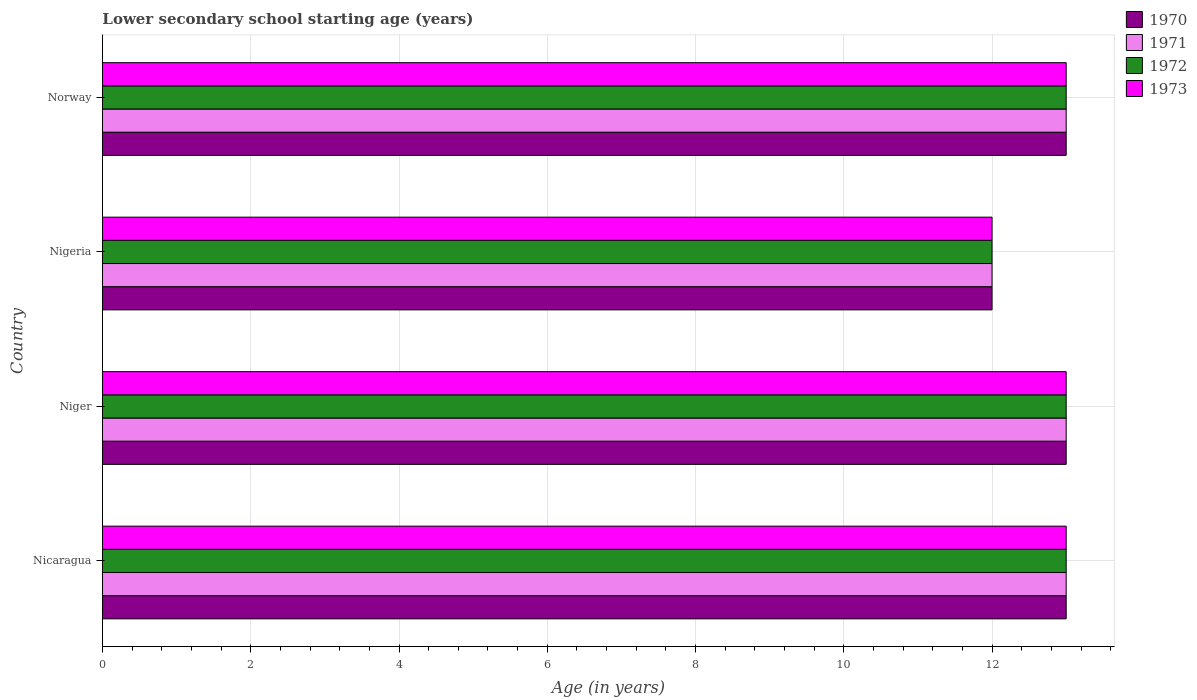How many different coloured bars are there?
Your answer should be very brief. 4. Are the number of bars per tick equal to the number of legend labels?
Your answer should be very brief. Yes. Are the number of bars on each tick of the Y-axis equal?
Provide a short and direct response. Yes. How many bars are there on the 1st tick from the top?
Make the answer very short. 4. How many bars are there on the 3rd tick from the bottom?
Give a very brief answer. 4. What is the label of the 2nd group of bars from the top?
Offer a very short reply. Nigeria. In which country was the lower secondary school starting age of children in 1970 maximum?
Your answer should be very brief. Nicaragua. In which country was the lower secondary school starting age of children in 1972 minimum?
Offer a very short reply. Nigeria. What is the difference between the lower secondary school starting age of children in 1971 in Nicaragua and that in Norway?
Your response must be concise. 0. What is the difference between the lower secondary school starting age of children in 1973 in Nigeria and the lower secondary school starting age of children in 1972 in Norway?
Your answer should be very brief. -1. What is the average lower secondary school starting age of children in 1973 per country?
Provide a short and direct response. 12.75. What is the difference between the lower secondary school starting age of children in 1970 and lower secondary school starting age of children in 1972 in Norway?
Provide a succinct answer. 0. In how many countries, is the lower secondary school starting age of children in 1971 greater than 11.6 years?
Offer a terse response. 4. What is the ratio of the lower secondary school starting age of children in 1972 in Niger to that in Nigeria?
Give a very brief answer. 1.08. In how many countries, is the lower secondary school starting age of children in 1973 greater than the average lower secondary school starting age of children in 1973 taken over all countries?
Provide a succinct answer. 3. Is the sum of the lower secondary school starting age of children in 1971 in Niger and Nigeria greater than the maximum lower secondary school starting age of children in 1972 across all countries?
Your response must be concise. Yes. Is it the case that in every country, the sum of the lower secondary school starting age of children in 1972 and lower secondary school starting age of children in 1971 is greater than the sum of lower secondary school starting age of children in 1973 and lower secondary school starting age of children in 1970?
Give a very brief answer. No. What does the 1st bar from the bottom in Niger represents?
Make the answer very short. 1970. Is it the case that in every country, the sum of the lower secondary school starting age of children in 1970 and lower secondary school starting age of children in 1973 is greater than the lower secondary school starting age of children in 1972?
Your response must be concise. Yes. How many bars are there?
Offer a terse response. 16. Are all the bars in the graph horizontal?
Your answer should be compact. Yes. Does the graph contain any zero values?
Ensure brevity in your answer.  No. Where does the legend appear in the graph?
Ensure brevity in your answer.  Top right. How are the legend labels stacked?
Keep it short and to the point. Vertical. What is the title of the graph?
Offer a very short reply. Lower secondary school starting age (years). Does "2011" appear as one of the legend labels in the graph?
Give a very brief answer. No. What is the label or title of the X-axis?
Your answer should be very brief. Age (in years). What is the label or title of the Y-axis?
Offer a very short reply. Country. What is the Age (in years) in 1970 in Nicaragua?
Provide a succinct answer. 13. What is the Age (in years) in 1971 in Nicaragua?
Provide a short and direct response. 13. What is the Age (in years) in 1972 in Nicaragua?
Provide a short and direct response. 13. What is the Age (in years) of 1973 in Nicaragua?
Your answer should be very brief. 13. What is the Age (in years) in 1971 in Niger?
Your answer should be very brief. 13. What is the Age (in years) of 1973 in Niger?
Provide a short and direct response. 13. What is the Age (in years) of 1970 in Norway?
Make the answer very short. 13. What is the Age (in years) of 1973 in Norway?
Offer a terse response. 13. Across all countries, what is the maximum Age (in years) of 1971?
Provide a short and direct response. 13. Across all countries, what is the maximum Age (in years) of 1972?
Your answer should be compact. 13. Across all countries, what is the maximum Age (in years) in 1973?
Provide a short and direct response. 13. Across all countries, what is the minimum Age (in years) in 1970?
Make the answer very short. 12. Across all countries, what is the minimum Age (in years) of 1972?
Your response must be concise. 12. What is the total Age (in years) of 1970 in the graph?
Offer a very short reply. 51. What is the total Age (in years) of 1972 in the graph?
Give a very brief answer. 51. What is the difference between the Age (in years) in 1970 in Nicaragua and that in Niger?
Give a very brief answer. 0. What is the difference between the Age (in years) in 1973 in Nicaragua and that in Niger?
Offer a very short reply. 0. What is the difference between the Age (in years) in 1971 in Nicaragua and that in Nigeria?
Give a very brief answer. 1. What is the difference between the Age (in years) in 1973 in Nicaragua and that in Nigeria?
Your answer should be compact. 1. What is the difference between the Age (in years) of 1973 in Nicaragua and that in Norway?
Your answer should be very brief. 0. What is the difference between the Age (in years) of 1972 in Niger and that in Nigeria?
Ensure brevity in your answer.  1. What is the difference between the Age (in years) in 1973 in Niger and that in Nigeria?
Give a very brief answer. 1. What is the difference between the Age (in years) in 1971 in Nigeria and that in Norway?
Your answer should be compact. -1. What is the difference between the Age (in years) of 1972 in Nigeria and that in Norway?
Keep it short and to the point. -1. What is the difference between the Age (in years) of 1973 in Nigeria and that in Norway?
Your answer should be compact. -1. What is the difference between the Age (in years) in 1970 in Nicaragua and the Age (in years) in 1971 in Niger?
Provide a short and direct response. 0. What is the difference between the Age (in years) in 1972 in Nicaragua and the Age (in years) in 1973 in Niger?
Provide a short and direct response. 0. What is the difference between the Age (in years) in 1970 in Nicaragua and the Age (in years) in 1971 in Nigeria?
Provide a succinct answer. 1. What is the difference between the Age (in years) in 1970 in Nicaragua and the Age (in years) in 1972 in Nigeria?
Offer a very short reply. 1. What is the difference between the Age (in years) of 1971 in Nicaragua and the Age (in years) of 1972 in Nigeria?
Ensure brevity in your answer.  1. What is the difference between the Age (in years) of 1970 in Nicaragua and the Age (in years) of 1971 in Norway?
Provide a short and direct response. 0. What is the difference between the Age (in years) of 1972 in Nicaragua and the Age (in years) of 1973 in Norway?
Provide a succinct answer. 0. What is the difference between the Age (in years) of 1970 in Niger and the Age (in years) of 1971 in Nigeria?
Offer a very short reply. 1. What is the difference between the Age (in years) in 1971 in Niger and the Age (in years) in 1972 in Nigeria?
Your answer should be very brief. 1. What is the difference between the Age (in years) in 1971 in Niger and the Age (in years) in 1973 in Nigeria?
Ensure brevity in your answer.  1. What is the difference between the Age (in years) of 1972 in Niger and the Age (in years) of 1973 in Nigeria?
Give a very brief answer. 1. What is the difference between the Age (in years) of 1970 in Niger and the Age (in years) of 1972 in Norway?
Ensure brevity in your answer.  0. What is the difference between the Age (in years) in 1971 in Niger and the Age (in years) in 1973 in Norway?
Your answer should be compact. 0. What is the difference between the Age (in years) of 1972 in Niger and the Age (in years) of 1973 in Norway?
Your answer should be very brief. 0. What is the difference between the Age (in years) of 1970 in Nigeria and the Age (in years) of 1972 in Norway?
Make the answer very short. -1. What is the difference between the Age (in years) in 1971 in Nigeria and the Age (in years) in 1972 in Norway?
Your answer should be very brief. -1. What is the difference between the Age (in years) of 1971 in Nigeria and the Age (in years) of 1973 in Norway?
Your answer should be very brief. -1. What is the average Age (in years) of 1970 per country?
Offer a very short reply. 12.75. What is the average Age (in years) of 1971 per country?
Offer a very short reply. 12.75. What is the average Age (in years) of 1972 per country?
Your answer should be very brief. 12.75. What is the average Age (in years) of 1973 per country?
Your answer should be very brief. 12.75. What is the difference between the Age (in years) of 1971 and Age (in years) of 1972 in Nicaragua?
Give a very brief answer. 0. What is the difference between the Age (in years) of 1971 and Age (in years) of 1973 in Nicaragua?
Your response must be concise. 0. What is the difference between the Age (in years) of 1970 and Age (in years) of 1971 in Niger?
Offer a terse response. 0. What is the difference between the Age (in years) of 1970 and Age (in years) of 1972 in Niger?
Your answer should be very brief. 0. What is the difference between the Age (in years) in 1970 and Age (in years) in 1973 in Niger?
Offer a terse response. 0. What is the difference between the Age (in years) in 1971 and Age (in years) in 1972 in Niger?
Offer a terse response. 0. What is the difference between the Age (in years) in 1971 and Age (in years) in 1973 in Nigeria?
Offer a very short reply. 0. What is the difference between the Age (in years) of 1970 and Age (in years) of 1971 in Norway?
Give a very brief answer. 0. What is the difference between the Age (in years) in 1970 and Age (in years) in 1972 in Norway?
Your response must be concise. 0. What is the difference between the Age (in years) of 1971 and Age (in years) of 1972 in Norway?
Give a very brief answer. 0. What is the ratio of the Age (in years) in 1973 in Nicaragua to that in Niger?
Provide a succinct answer. 1. What is the ratio of the Age (in years) in 1972 in Nicaragua to that in Nigeria?
Your answer should be very brief. 1.08. What is the ratio of the Age (in years) in 1970 in Nicaragua to that in Norway?
Your response must be concise. 1. What is the ratio of the Age (in years) in 1971 in Nicaragua to that in Norway?
Offer a terse response. 1. What is the ratio of the Age (in years) of 1973 in Niger to that in Nigeria?
Offer a terse response. 1.08. What is the ratio of the Age (in years) of 1971 in Niger to that in Norway?
Offer a terse response. 1. What is the ratio of the Age (in years) in 1972 in Nigeria to that in Norway?
Offer a terse response. 0.92. What is the ratio of the Age (in years) of 1973 in Nigeria to that in Norway?
Offer a very short reply. 0.92. What is the difference between the highest and the second highest Age (in years) of 1970?
Make the answer very short. 0. What is the difference between the highest and the second highest Age (in years) of 1972?
Give a very brief answer. 0. What is the difference between the highest and the lowest Age (in years) in 1970?
Your response must be concise. 1. What is the difference between the highest and the lowest Age (in years) in 1972?
Offer a terse response. 1. 